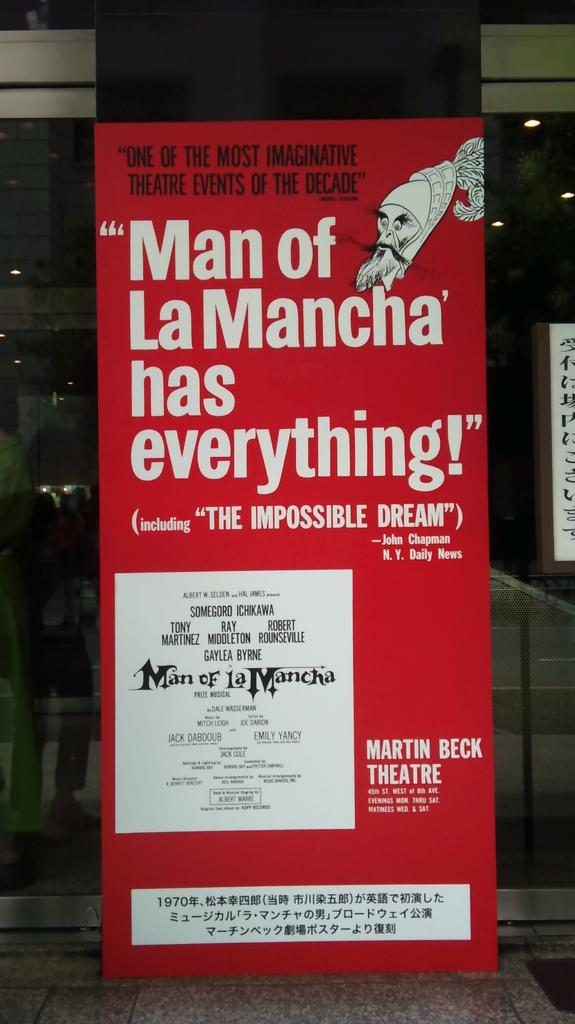<image>
Present a compact description of the photo's key features. A red poster advertising The Man of LaMancha. 